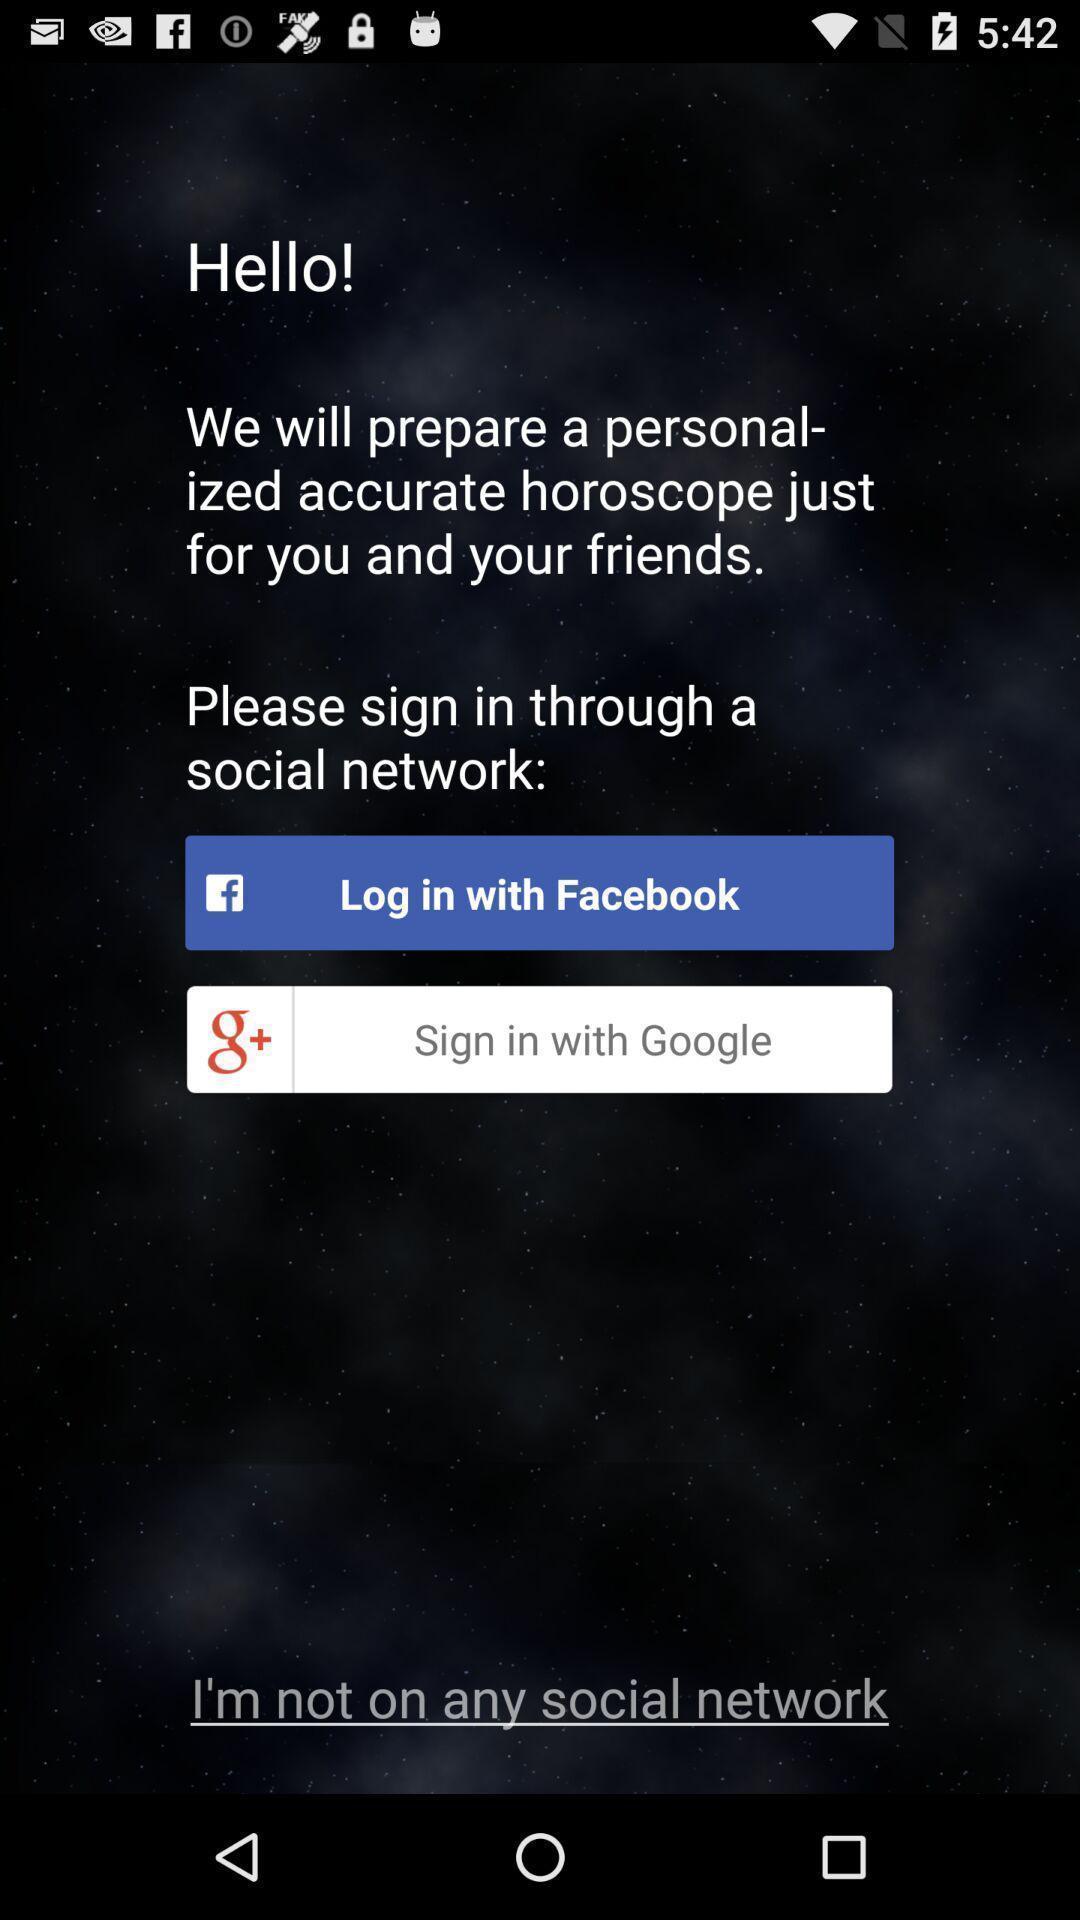What can you discern from this picture? Popup of text to get the horoscope with login option. 